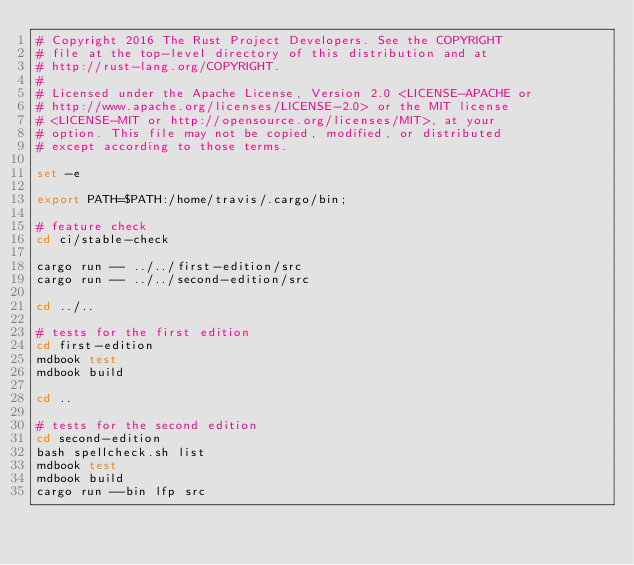Convert code to text. <code><loc_0><loc_0><loc_500><loc_500><_Bash_># Copyright 2016 The Rust Project Developers. See the COPYRIGHT
# file at the top-level directory of this distribution and at
# http://rust-lang.org/COPYRIGHT.
#
# Licensed under the Apache License, Version 2.0 <LICENSE-APACHE or
# http://www.apache.org/licenses/LICENSE-2.0> or the MIT license
# <LICENSE-MIT or http://opensource.org/licenses/MIT>, at your
# option. This file may not be copied, modified, or distributed
# except according to those terms.

set -e

export PATH=$PATH:/home/travis/.cargo/bin;

# feature check
cd ci/stable-check

cargo run -- ../../first-edition/src
cargo run -- ../../second-edition/src

cd ../..

# tests for the first edition
cd first-edition
mdbook test
mdbook build

cd ..

# tests for the second edition
cd second-edition
bash spellcheck.sh list
mdbook test
mdbook build
cargo run --bin lfp src
</code> 